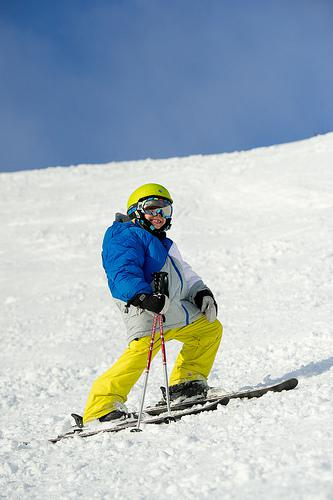Question: what color are the boys pants?
Choices:
A. Green.
B. Blue.
C. Yellow.
D. Red.
Answer with the letter. Answer: C Question: who is in the picture?
Choices:
A. A girl.
B. A man.
C. A boy.
D. A woman.
Answer with the letter. Answer: C Question: what is his holding?
Choices:
A. Ski poles.
B. Gloves.
C. Baby.
D. Keys.
Answer with the letter. Answer: A Question: what is on the ground?
Choices:
A. Snow.
B. Water.
C. Carpet.
D. Trash.
Answer with the letter. Answer: A 